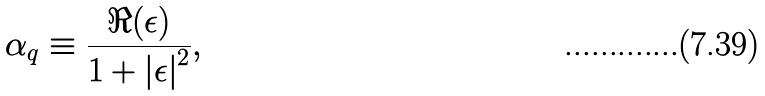Convert formula to latex. <formula><loc_0><loc_0><loc_500><loc_500>\alpha _ { q } \equiv \frac { \Re ( \epsilon ) } { 1 + \left | \epsilon \right | ^ { 2 } } ,</formula> 